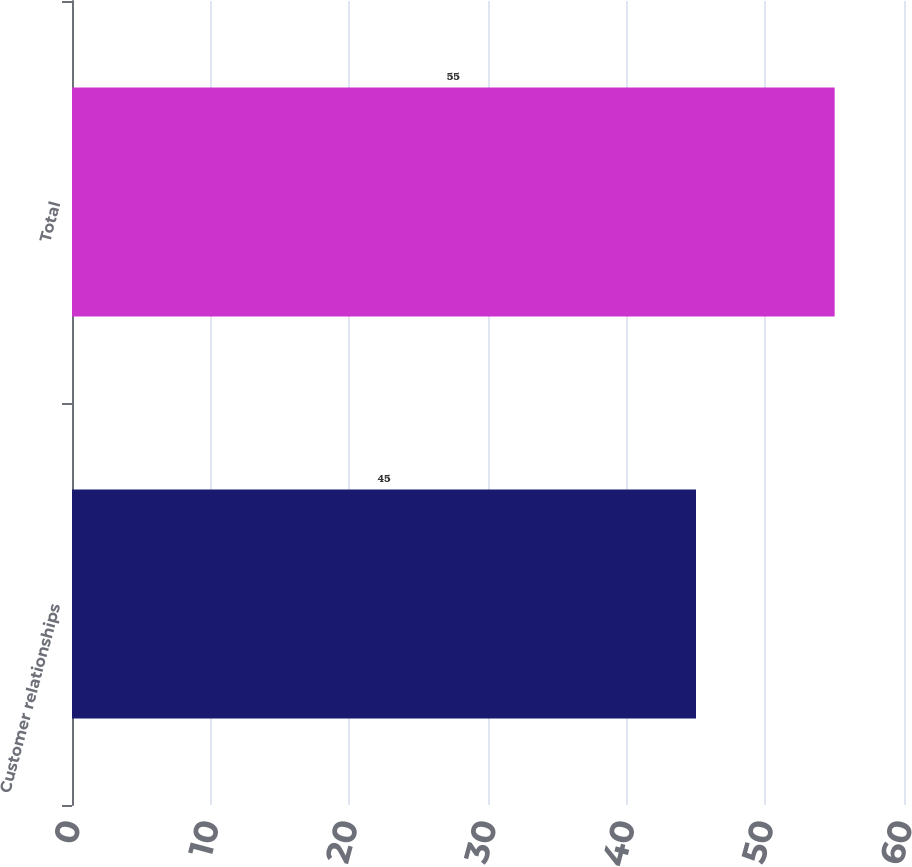<chart> <loc_0><loc_0><loc_500><loc_500><bar_chart><fcel>Customer relationships<fcel>Total<nl><fcel>45<fcel>55<nl></chart> 